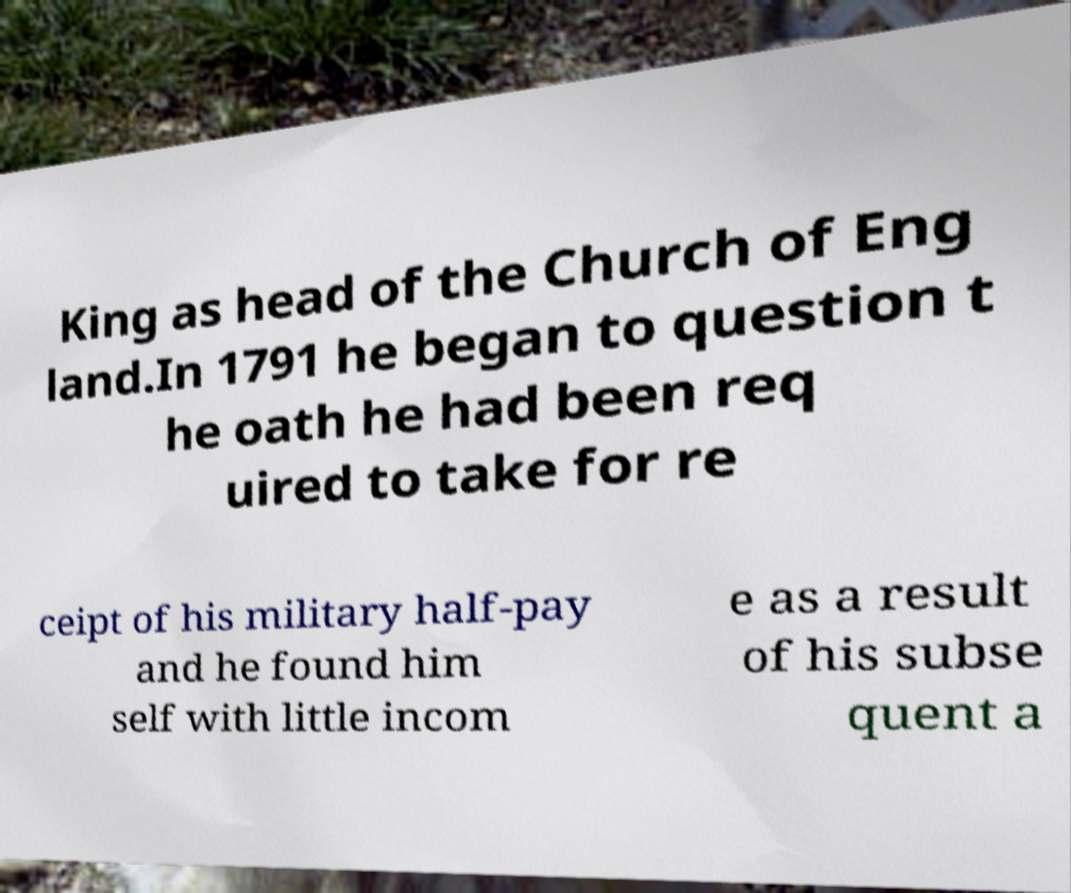Please read and relay the text visible in this image. What does it say? King as head of the Church of Eng land.In 1791 he began to question t he oath he had been req uired to take for re ceipt of his military half-pay and he found him self with little incom e as a result of his subse quent a 